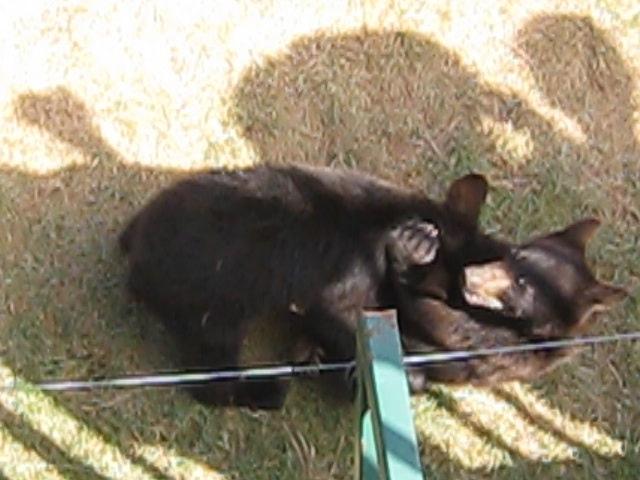What is the bear doing?
Keep it brief. Playing. How many of these animals is alive?
Short answer required. 2. How many ears can you see?
Concise answer only. 2. What type of animal is this?
Keep it brief. Bear. What kind of animals are these?
Short answer required. Bears. Does this bear look comfortable?
Keep it brief. Yes. 